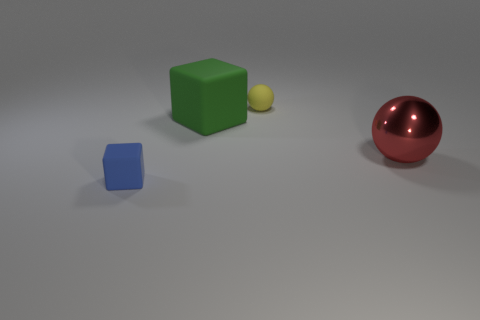Add 1 tiny cyan cubes. How many objects exist? 5 Add 1 yellow matte things. How many yellow matte things exist? 2 Subtract 0 cyan balls. How many objects are left? 4 Subtract all large red metallic objects. Subtract all red rubber objects. How many objects are left? 3 Add 3 blue matte things. How many blue matte things are left? 4 